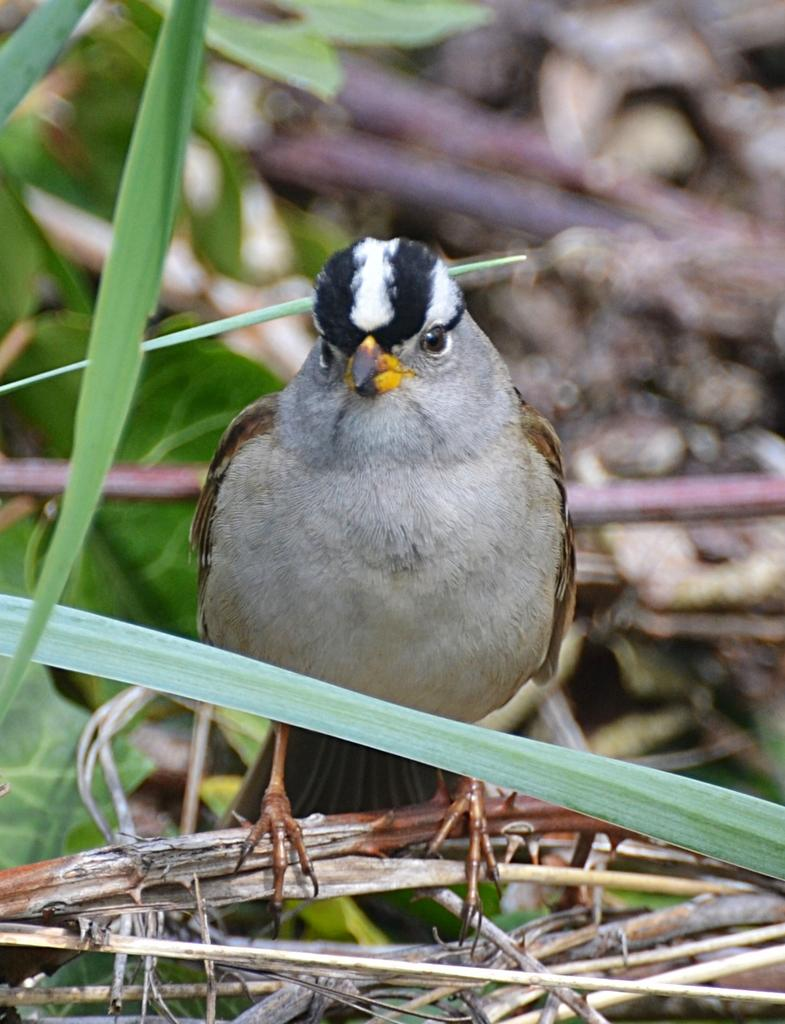What type of animal can be seen in the image? There is a bird in the image. Where is the bird located in the image? The bird is on a branch. What else can be seen on the branch in the image? There are branches visible in the image. What type of vegetation is present in the image? There are leaves in the image. How much money does the bird have in the image? There is no indication of money in the image; it features a bird on a branch with leaves and branches. 